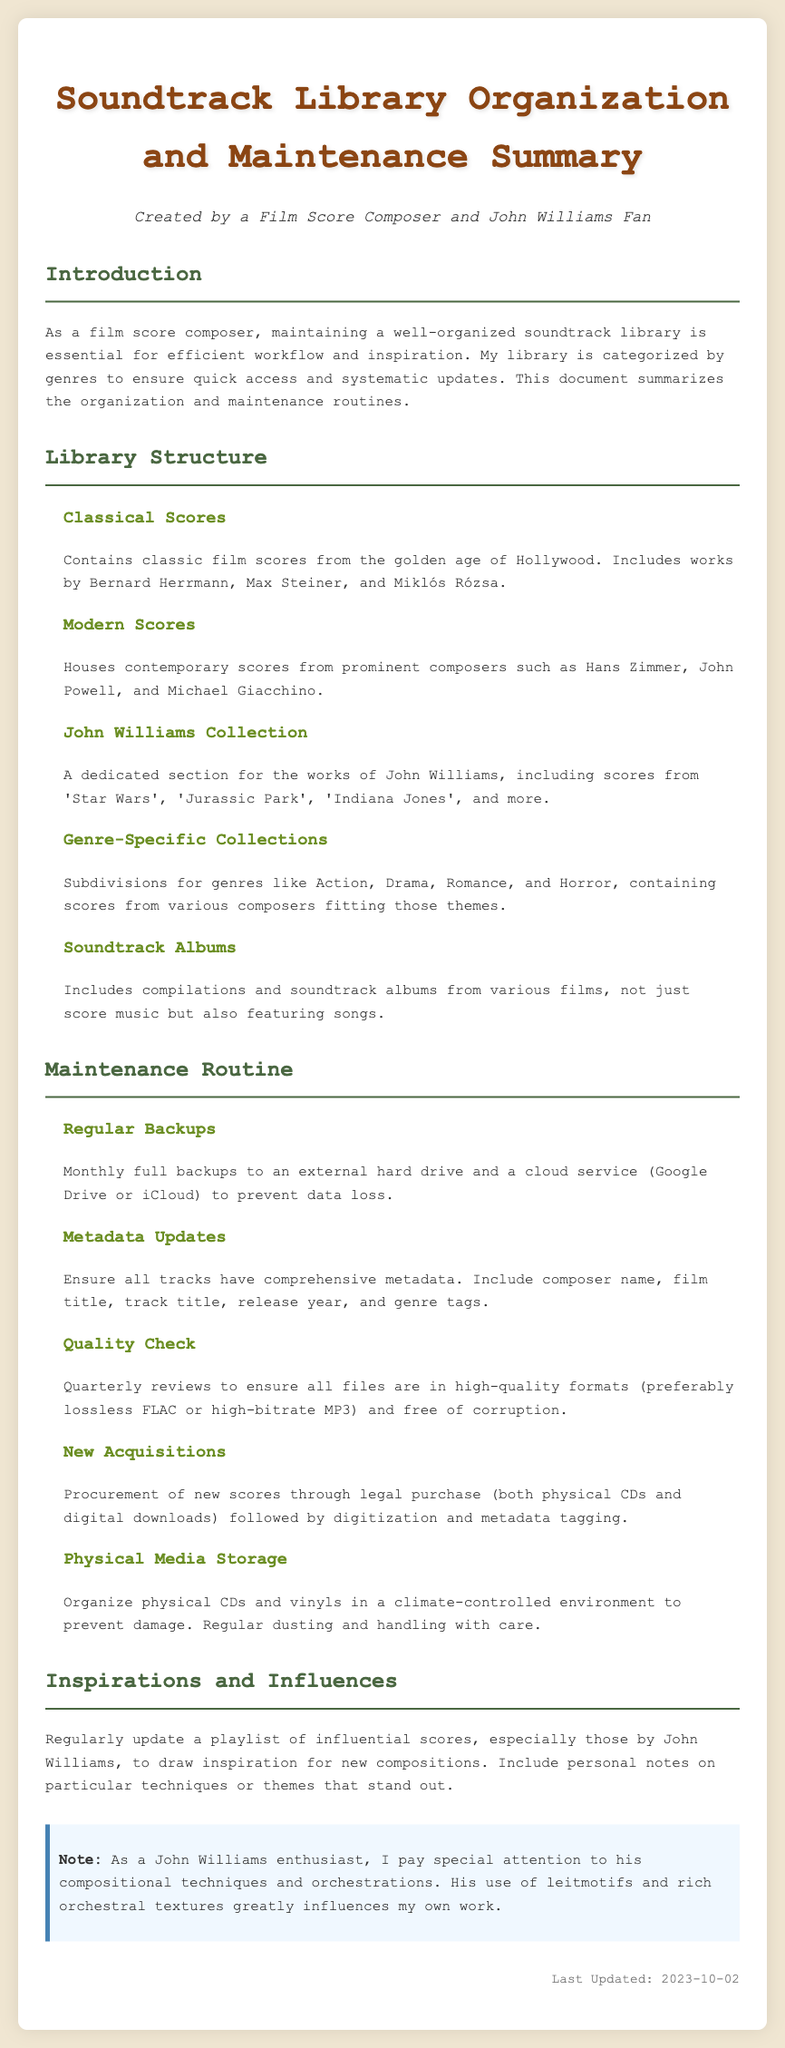What is the primary genre of the collection dedicated to John Williams? The section specifically mentions "John Williams Collection," highlighting the focus on his works.
Answer: John Williams Collection How often are regular backups performed? The maintenance log states that backups are done monthly, emphasizing the routine's frequency.
Answer: Monthly What is the format preference for quality files? The document specifies that high-quality formats are preferred, particularly mentioning lossless FLAC or high-bitrate MP3.
Answer: Lossless FLAC or high-bitrate MP3 Who are some composers included in the Classical Scores section? The log lists Bernard Herrmann, Max Steiner, and Miklós Rózsa as notable classic composers in that genre.
Answer: Bernard Herrmann, Max Steiner, Miklós Rózsa What maintenance task involves ensuring comprehensive track information? The maintenance routine describes metadata updates as crucial for maintaining the collection's organization.
Answer: Metadata Updates How many times a year are quality checks performed? The document indicates that quality checks are reviewed quarterly, which amounts to four times a year.
Answer: Quarterly In which section can you find scores categorized by Action, Drama, Romance, and Horror? The log categorically refers to genre-specific subdivisions within the soundtrack library organization that contain these scores.
Answer: Genre-Specific Collections What is noted about the physical media storage environment? The document specifies that the physical media should be stored in a climate-controlled environment to prevent damage.
Answer: Climate-controlled environment What is the last updated date mentioned in the document? The log includes a last updated date at the bottom of the summary, providing a specific reference for document revisions.
Answer: 2023-10-02 